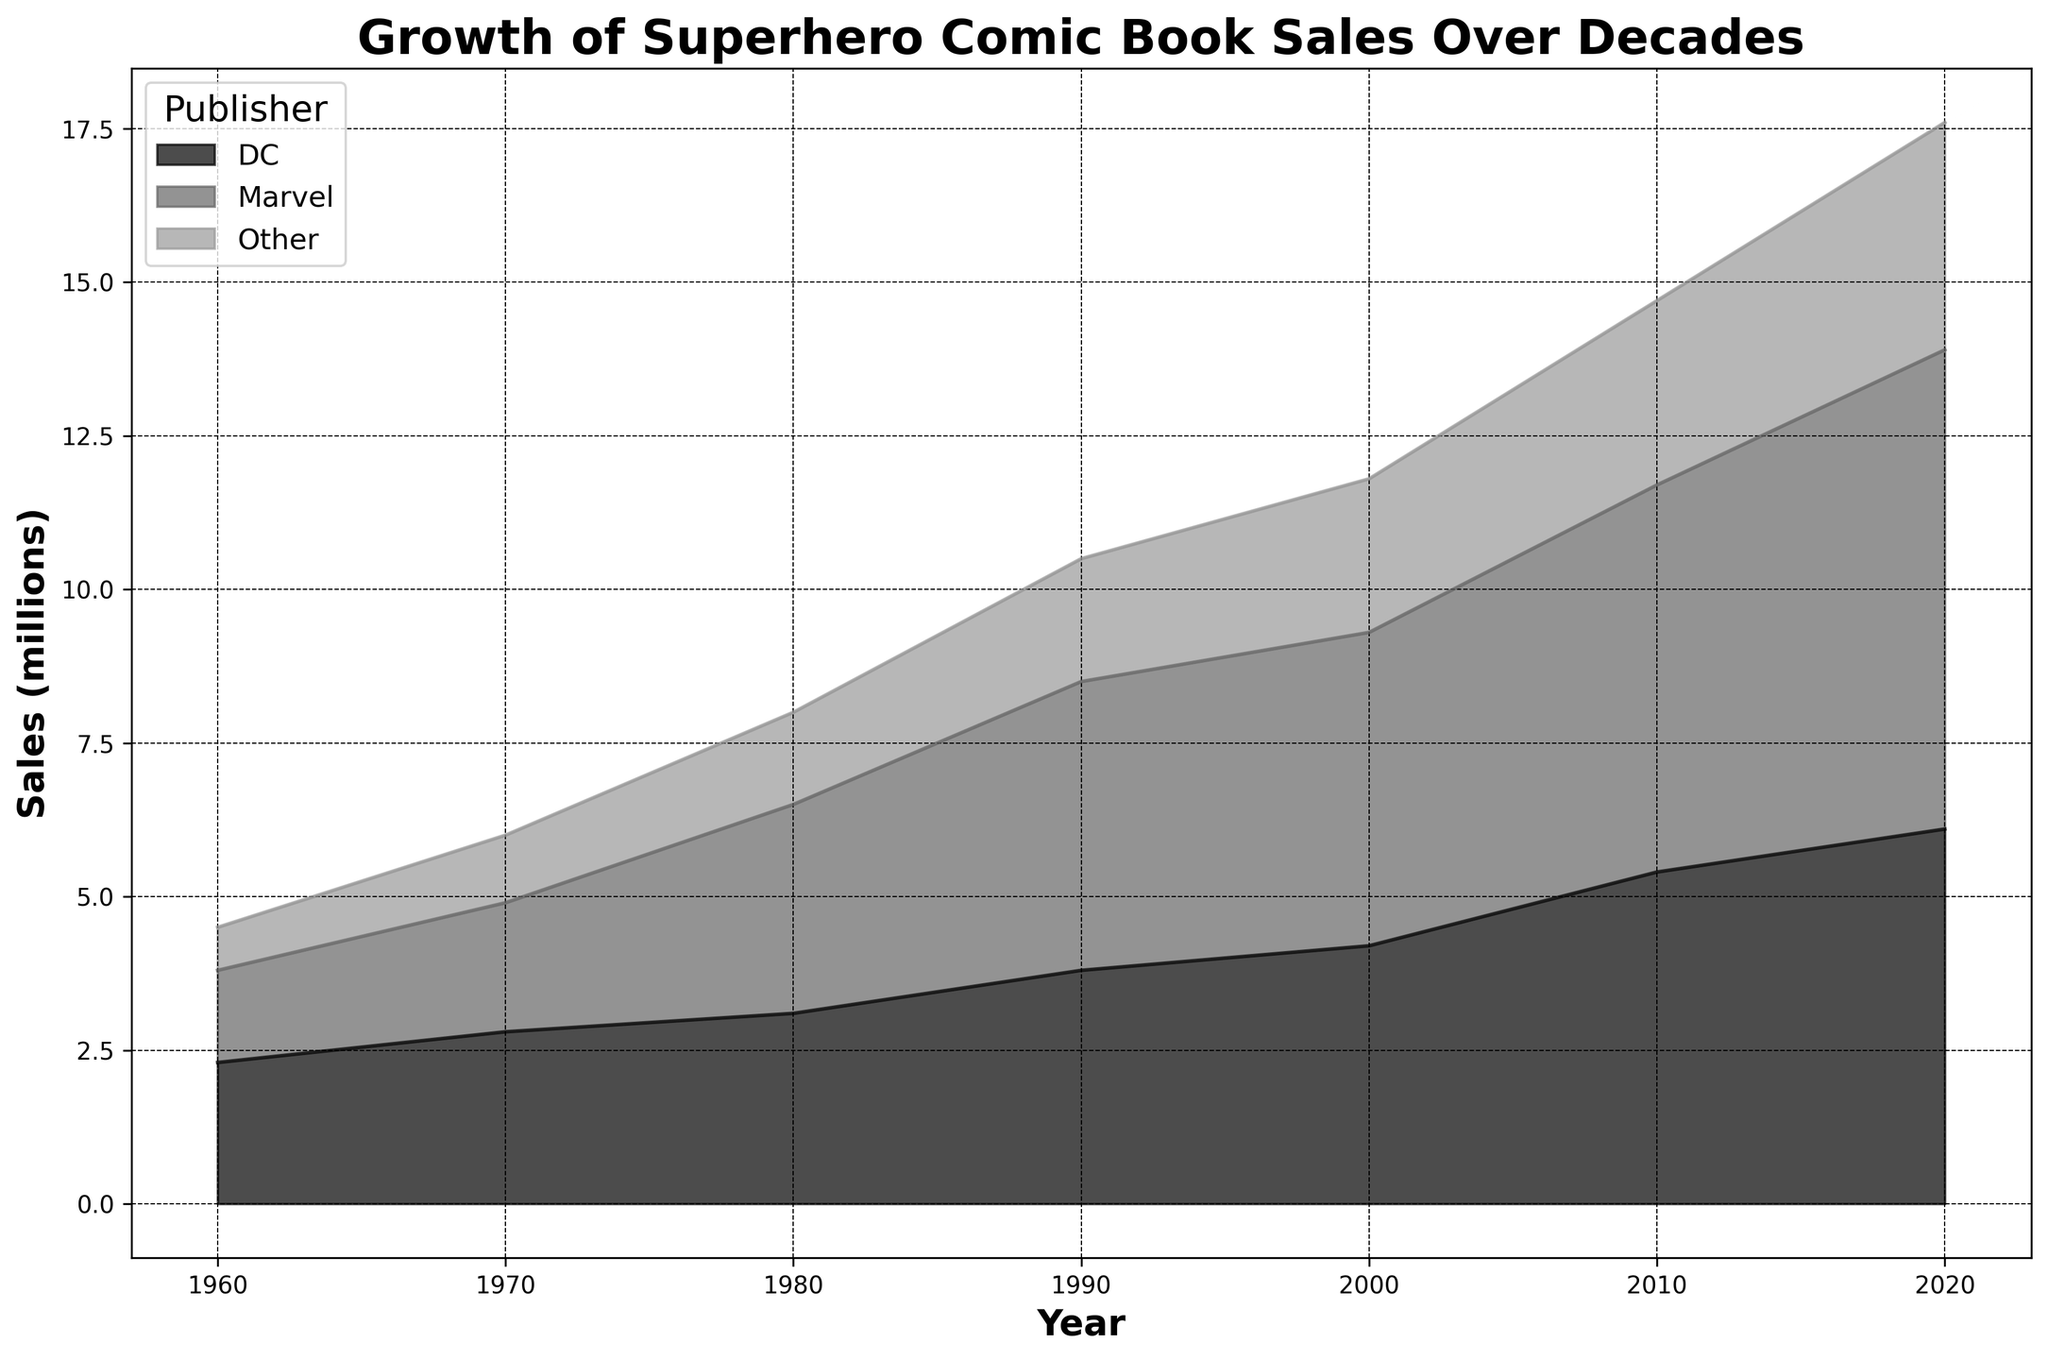What is the total sales for Marvel in 2020? First, locate the data for Marvel in the year 2020 and read the value which is 7.8 million.
Answer: 7.8 million How do the sales of DC in 1980 compare to the sales of Other in the same year? Find the values for DC and Other in 1980. DC is 3.1 million and Other is 1.5 million. DC sales are higher than Other.
Answer: DC sales are higher Which year shows the highest total sales across all publishers? Sum the sales for all publishers for each year: 1960 - (1.5+2.3+0.7) = 4.5, 1970 - (2.1+2.8+1.1) = 6.0, 1980 - (3.4+3.1+1.5) = 8.0, 1990 - (4.7+3.8+2.0) = 10.5, 2000 - (5.1+4.2+2.5) = 11.8, 2010 - (6.3+5.4+3.0) = 14.7, 2020 - (7.8+6.1+3.7) = 17.6. The highest total is in 2020.
Answer: 2020 What is the difference in sales between Marvel and DC in 1990? Find the sales values for Marvel and DC in 1990, which are 4.7 and 3.8 million, respectively. Subtract the DC sales from Marvel sales: 4.7 - 3.8 = 0.9 million.
Answer: 0.9 million How does the trend of Other publisher's sales change from 1960 to 2020? Observe the sales values: 1960 is 0.7, 1970 is 1.1, 1980 is 1.5, 1990 is 2.0, 2000 is 2.5, 2010 is 3.0, 2020 is 3.7. The sales of Other steadily increased over time.
Answer: Steadily increased Which publisher saw the largest increase in sales from 2000 to 2010? Calculate the increase for each publisher: Marvel - (6.3-5.1) = 1.2 million, DC - (5.4-4.2) = 1.2 million, Other - (3.0-2.5) = 0.5 million. Marvel and DC both had the largest increase.
Answer: Marvel and DC In which decade did Marvel's sales grow the most? Calculate the sales growth for Marvel for each decade: 1960-1970 (2.1-1.5)=0.6, 1970-1980 (3.4-2.1)=1.3, 1980-1990 (4.7-3.4)=1.3, 1990-2000 (5.1-4.7)=0.4, 2000-2010 (6.3-5.1)=1.2, 2010-2020 (7.8-6.3)=1.5. The largest growth was from 2010 to 2020.
Answer: 2010-2020 